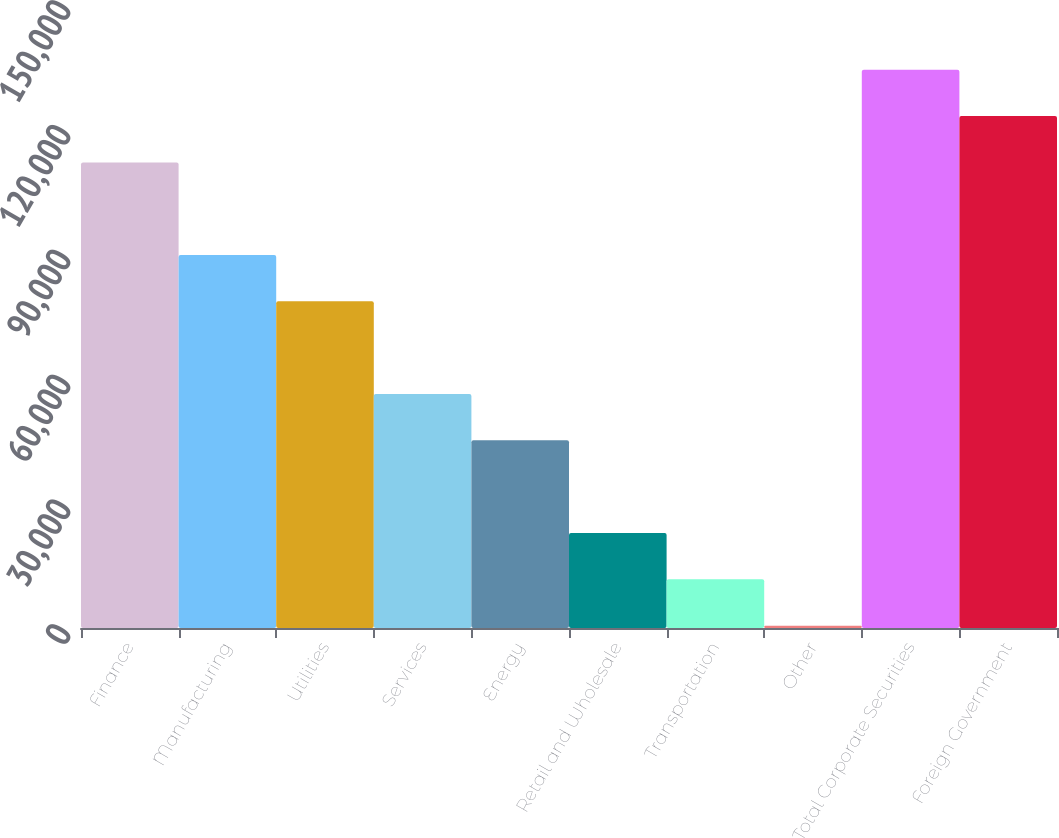<chart> <loc_0><loc_0><loc_500><loc_500><bar_chart><fcel>Finance<fcel>Manufacturing<fcel>Utilities<fcel>Services<fcel>Energy<fcel>Retail and Wholesale<fcel>Transportation<fcel>Other<fcel>Total Corporate Securities<fcel>Foreign Government<nl><fcel>111929<fcel>89655.8<fcel>78519.2<fcel>56246<fcel>45109.4<fcel>22836.2<fcel>11699.6<fcel>563<fcel>134202<fcel>123066<nl></chart> 